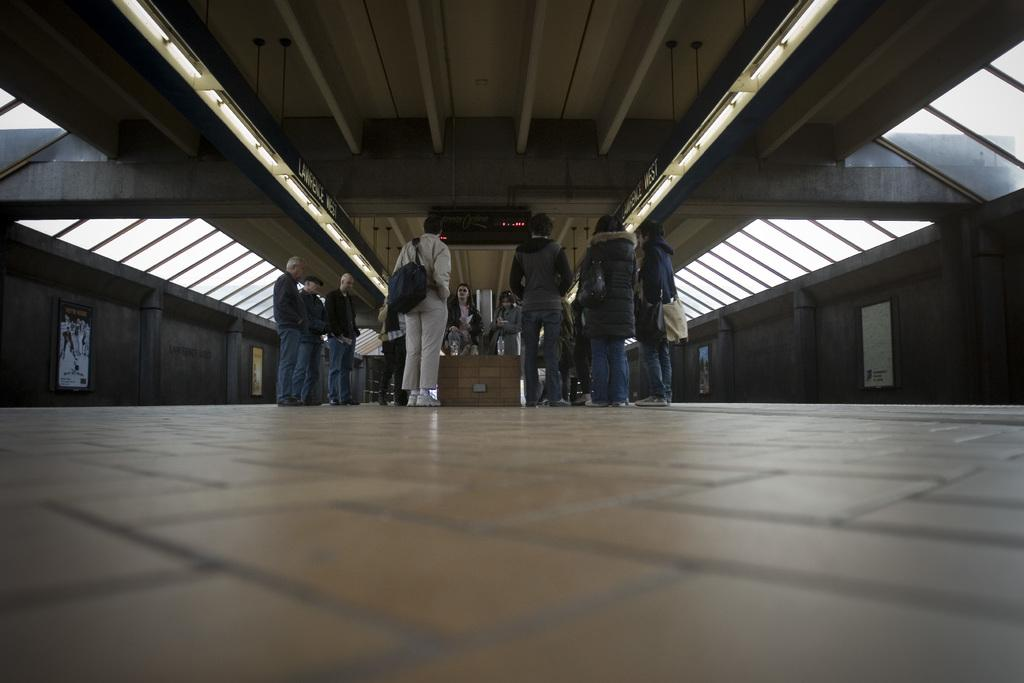What is the main subject of the image? The main subject of the image is people standing in the center. Where are the people standing? The people are standing on the floor. What can be seen above the people in the image? There is a ceiling visible at the top of the image. What surrounds the people on both sides in the image? There are walls on both sides of the image. Are there any wax sculptures of potatoes with long necks in the image? No, there are no wax sculptures of potatoes with long necks in the image. 